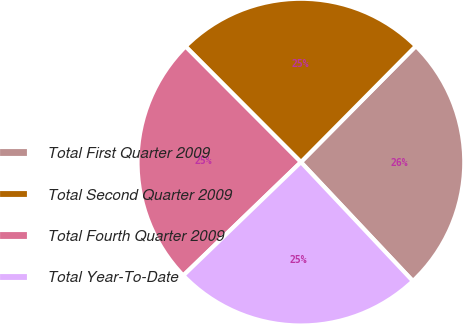Convert chart. <chart><loc_0><loc_0><loc_500><loc_500><pie_chart><fcel>Total First Quarter 2009<fcel>Total Second Quarter 2009<fcel>Total Fourth Quarter 2009<fcel>Total Year-To-Date<nl><fcel>25.56%<fcel>24.9%<fcel>24.73%<fcel>24.81%<nl></chart> 